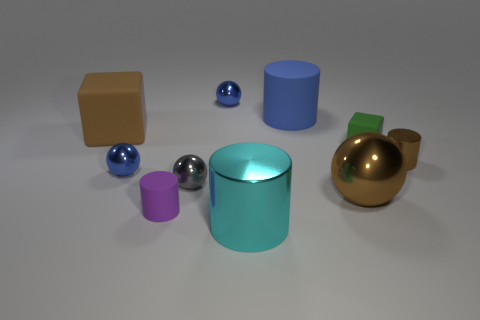There is a cylinder that is in front of the large brown matte block and behind the tiny gray sphere; what is its color?
Ensure brevity in your answer.  Brown. There is a shiny cylinder behind the large cyan cylinder; what size is it?
Your answer should be very brief. Small. What number of things are made of the same material as the green cube?
Offer a terse response. 3. There is a rubber object that is the same color as the tiny metallic cylinder; what is its shape?
Keep it short and to the point. Cube. Is the shape of the small blue object that is in front of the big brown matte thing the same as  the tiny purple matte thing?
Keep it short and to the point. No. What is the color of the other big cylinder that is the same material as the brown cylinder?
Your answer should be very brief. Cyan. There is a big matte thing that is to the left of the large thing in front of the purple rubber cylinder; are there any cyan objects that are in front of it?
Provide a short and direct response. Yes. The green thing is what shape?
Provide a succinct answer. Cube. Is the number of tiny gray spheres that are right of the large metal cylinder less than the number of blue metallic objects?
Your response must be concise. Yes. Is there a tiny blue metallic object of the same shape as the tiny gray metallic object?
Your response must be concise. Yes. 